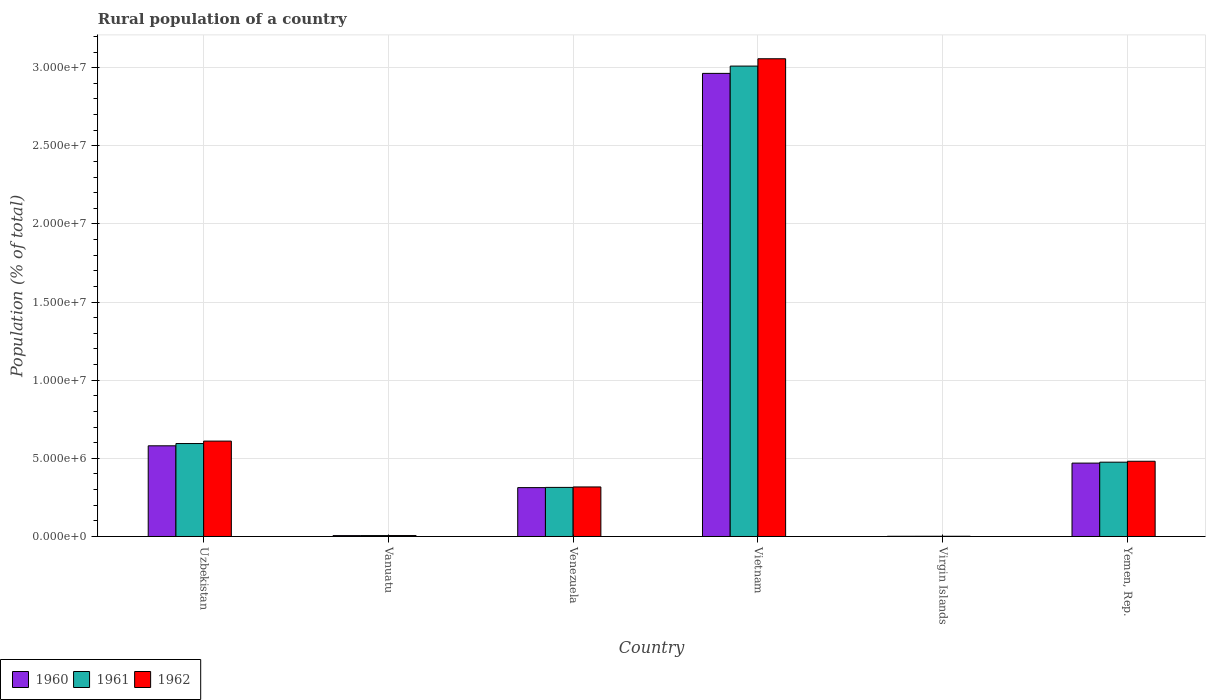Are the number of bars per tick equal to the number of legend labels?
Your answer should be very brief. Yes. Are the number of bars on each tick of the X-axis equal?
Make the answer very short. Yes. How many bars are there on the 3rd tick from the left?
Keep it short and to the point. 3. What is the label of the 1st group of bars from the left?
Offer a very short reply. Uzbekistan. What is the rural population in 1961 in Vietnam?
Your response must be concise. 3.01e+07. Across all countries, what is the maximum rural population in 1960?
Make the answer very short. 2.96e+07. Across all countries, what is the minimum rural population in 1960?
Your response must be concise. 1.39e+04. In which country was the rural population in 1961 maximum?
Provide a succinct answer. Vietnam. In which country was the rural population in 1960 minimum?
Ensure brevity in your answer.  Virgin Islands. What is the total rural population in 1962 in the graph?
Provide a succinct answer. 4.47e+07. What is the difference between the rural population in 1960 in Venezuela and that in Vietnam?
Provide a succinct answer. -2.65e+07. What is the difference between the rural population in 1962 in Vanuatu and the rural population in 1961 in Uzbekistan?
Provide a succinct answer. -5.89e+06. What is the average rural population in 1961 per country?
Your answer should be compact. 7.34e+06. What is the difference between the rural population of/in 1962 and rural population of/in 1960 in Venezuela?
Your response must be concise. 4.32e+04. In how many countries, is the rural population in 1961 greater than 27000000 %?
Provide a succinct answer. 1. What is the ratio of the rural population in 1962 in Vanuatu to that in Vietnam?
Provide a succinct answer. 0. Is the rural population in 1962 in Venezuela less than that in Vietnam?
Your answer should be very brief. Yes. Is the difference between the rural population in 1962 in Vietnam and Virgin Islands greater than the difference between the rural population in 1960 in Vietnam and Virgin Islands?
Your answer should be compact. Yes. What is the difference between the highest and the second highest rural population in 1961?
Provide a succinct answer. 2.53e+07. What is the difference between the highest and the lowest rural population in 1962?
Ensure brevity in your answer.  3.06e+07. Is the sum of the rural population in 1961 in Vanuatu and Venezuela greater than the maximum rural population in 1960 across all countries?
Your answer should be compact. No. What does the 3rd bar from the left in Vanuatu represents?
Keep it short and to the point. 1962. Are all the bars in the graph horizontal?
Your response must be concise. No. What is the difference between two consecutive major ticks on the Y-axis?
Your answer should be very brief. 5.00e+06. Are the values on the major ticks of Y-axis written in scientific E-notation?
Give a very brief answer. Yes. How are the legend labels stacked?
Offer a very short reply. Horizontal. What is the title of the graph?
Provide a short and direct response. Rural population of a country. What is the label or title of the Y-axis?
Ensure brevity in your answer.  Population (% of total). What is the Population (% of total) of 1960 in Uzbekistan?
Offer a terse response. 5.80e+06. What is the Population (% of total) in 1961 in Uzbekistan?
Offer a terse response. 5.95e+06. What is the Population (% of total) of 1962 in Uzbekistan?
Your response must be concise. 6.10e+06. What is the Population (% of total) of 1960 in Vanuatu?
Make the answer very short. 5.71e+04. What is the Population (% of total) of 1961 in Vanuatu?
Give a very brief answer. 5.88e+04. What is the Population (% of total) in 1962 in Vanuatu?
Your answer should be compact. 6.05e+04. What is the Population (% of total) of 1960 in Venezuela?
Your answer should be very brief. 3.13e+06. What is the Population (% of total) in 1961 in Venezuela?
Offer a terse response. 3.14e+06. What is the Population (% of total) of 1962 in Venezuela?
Your answer should be very brief. 3.17e+06. What is the Population (% of total) in 1960 in Vietnam?
Your response must be concise. 2.96e+07. What is the Population (% of total) of 1961 in Vietnam?
Your response must be concise. 3.01e+07. What is the Population (% of total) in 1962 in Vietnam?
Offer a very short reply. 3.06e+07. What is the Population (% of total) in 1960 in Virgin Islands?
Ensure brevity in your answer.  1.39e+04. What is the Population (% of total) of 1961 in Virgin Islands?
Ensure brevity in your answer.  1.44e+04. What is the Population (% of total) in 1962 in Virgin Islands?
Your answer should be compact. 1.48e+04. What is the Population (% of total) of 1960 in Yemen, Rep.?
Make the answer very short. 4.70e+06. What is the Population (% of total) of 1961 in Yemen, Rep.?
Offer a very short reply. 4.75e+06. What is the Population (% of total) in 1962 in Yemen, Rep.?
Provide a short and direct response. 4.81e+06. Across all countries, what is the maximum Population (% of total) in 1960?
Keep it short and to the point. 2.96e+07. Across all countries, what is the maximum Population (% of total) in 1961?
Make the answer very short. 3.01e+07. Across all countries, what is the maximum Population (% of total) in 1962?
Keep it short and to the point. 3.06e+07. Across all countries, what is the minimum Population (% of total) in 1960?
Make the answer very short. 1.39e+04. Across all countries, what is the minimum Population (% of total) of 1961?
Your answer should be very brief. 1.44e+04. Across all countries, what is the minimum Population (% of total) of 1962?
Make the answer very short. 1.48e+04. What is the total Population (% of total) of 1960 in the graph?
Your answer should be compact. 4.33e+07. What is the total Population (% of total) in 1961 in the graph?
Your response must be concise. 4.40e+07. What is the total Population (% of total) in 1962 in the graph?
Provide a short and direct response. 4.47e+07. What is the difference between the Population (% of total) in 1960 in Uzbekistan and that in Vanuatu?
Your answer should be very brief. 5.75e+06. What is the difference between the Population (% of total) in 1961 in Uzbekistan and that in Vanuatu?
Your answer should be very brief. 5.89e+06. What is the difference between the Population (% of total) of 1962 in Uzbekistan and that in Vanuatu?
Offer a very short reply. 6.04e+06. What is the difference between the Population (% of total) of 1960 in Uzbekistan and that in Venezuela?
Provide a succinct answer. 2.68e+06. What is the difference between the Population (% of total) of 1961 in Uzbekistan and that in Venezuela?
Offer a terse response. 2.81e+06. What is the difference between the Population (% of total) in 1962 in Uzbekistan and that in Venezuela?
Offer a very short reply. 2.93e+06. What is the difference between the Population (% of total) of 1960 in Uzbekistan and that in Vietnam?
Ensure brevity in your answer.  -2.38e+07. What is the difference between the Population (% of total) of 1961 in Uzbekistan and that in Vietnam?
Your response must be concise. -2.42e+07. What is the difference between the Population (% of total) in 1962 in Uzbekistan and that in Vietnam?
Ensure brevity in your answer.  -2.45e+07. What is the difference between the Population (% of total) of 1960 in Uzbekistan and that in Virgin Islands?
Your answer should be compact. 5.79e+06. What is the difference between the Population (% of total) in 1961 in Uzbekistan and that in Virgin Islands?
Offer a terse response. 5.93e+06. What is the difference between the Population (% of total) in 1962 in Uzbekistan and that in Virgin Islands?
Provide a succinct answer. 6.09e+06. What is the difference between the Population (% of total) in 1960 in Uzbekistan and that in Yemen, Rep.?
Your response must be concise. 1.11e+06. What is the difference between the Population (% of total) in 1961 in Uzbekistan and that in Yemen, Rep.?
Provide a succinct answer. 1.19e+06. What is the difference between the Population (% of total) of 1962 in Uzbekistan and that in Yemen, Rep.?
Make the answer very short. 1.29e+06. What is the difference between the Population (% of total) of 1960 in Vanuatu and that in Venezuela?
Provide a short and direct response. -3.07e+06. What is the difference between the Population (% of total) in 1961 in Vanuatu and that in Venezuela?
Give a very brief answer. -3.08e+06. What is the difference between the Population (% of total) in 1962 in Vanuatu and that in Venezuela?
Your answer should be very brief. -3.11e+06. What is the difference between the Population (% of total) in 1960 in Vanuatu and that in Vietnam?
Your response must be concise. -2.96e+07. What is the difference between the Population (% of total) of 1961 in Vanuatu and that in Vietnam?
Keep it short and to the point. -3.00e+07. What is the difference between the Population (% of total) of 1962 in Vanuatu and that in Vietnam?
Offer a terse response. -3.05e+07. What is the difference between the Population (% of total) in 1960 in Vanuatu and that in Virgin Islands?
Make the answer very short. 4.31e+04. What is the difference between the Population (% of total) of 1961 in Vanuatu and that in Virgin Islands?
Provide a succinct answer. 4.44e+04. What is the difference between the Population (% of total) of 1962 in Vanuatu and that in Virgin Islands?
Ensure brevity in your answer.  4.57e+04. What is the difference between the Population (% of total) of 1960 in Vanuatu and that in Yemen, Rep.?
Give a very brief answer. -4.64e+06. What is the difference between the Population (% of total) of 1961 in Vanuatu and that in Yemen, Rep.?
Ensure brevity in your answer.  -4.70e+06. What is the difference between the Population (% of total) of 1962 in Vanuatu and that in Yemen, Rep.?
Provide a short and direct response. -4.75e+06. What is the difference between the Population (% of total) of 1960 in Venezuela and that in Vietnam?
Your answer should be compact. -2.65e+07. What is the difference between the Population (% of total) of 1961 in Venezuela and that in Vietnam?
Your answer should be very brief. -2.70e+07. What is the difference between the Population (% of total) in 1962 in Venezuela and that in Vietnam?
Provide a short and direct response. -2.74e+07. What is the difference between the Population (% of total) in 1960 in Venezuela and that in Virgin Islands?
Provide a short and direct response. 3.11e+06. What is the difference between the Population (% of total) in 1961 in Venezuela and that in Virgin Islands?
Your answer should be very brief. 3.13e+06. What is the difference between the Population (% of total) of 1962 in Venezuela and that in Virgin Islands?
Provide a short and direct response. 3.16e+06. What is the difference between the Population (% of total) in 1960 in Venezuela and that in Yemen, Rep.?
Ensure brevity in your answer.  -1.57e+06. What is the difference between the Population (% of total) in 1961 in Venezuela and that in Yemen, Rep.?
Provide a succinct answer. -1.61e+06. What is the difference between the Population (% of total) of 1962 in Venezuela and that in Yemen, Rep.?
Your answer should be very brief. -1.64e+06. What is the difference between the Population (% of total) in 1960 in Vietnam and that in Virgin Islands?
Make the answer very short. 2.96e+07. What is the difference between the Population (% of total) in 1961 in Vietnam and that in Virgin Islands?
Keep it short and to the point. 3.01e+07. What is the difference between the Population (% of total) of 1962 in Vietnam and that in Virgin Islands?
Your answer should be compact. 3.06e+07. What is the difference between the Population (% of total) in 1960 in Vietnam and that in Yemen, Rep.?
Your response must be concise. 2.49e+07. What is the difference between the Population (% of total) in 1961 in Vietnam and that in Yemen, Rep.?
Offer a terse response. 2.53e+07. What is the difference between the Population (% of total) of 1962 in Vietnam and that in Yemen, Rep.?
Make the answer very short. 2.58e+07. What is the difference between the Population (% of total) of 1960 in Virgin Islands and that in Yemen, Rep.?
Provide a short and direct response. -4.68e+06. What is the difference between the Population (% of total) in 1961 in Virgin Islands and that in Yemen, Rep.?
Give a very brief answer. -4.74e+06. What is the difference between the Population (% of total) in 1962 in Virgin Islands and that in Yemen, Rep.?
Provide a succinct answer. -4.80e+06. What is the difference between the Population (% of total) of 1960 in Uzbekistan and the Population (% of total) of 1961 in Vanuatu?
Your response must be concise. 5.74e+06. What is the difference between the Population (% of total) of 1960 in Uzbekistan and the Population (% of total) of 1962 in Vanuatu?
Your response must be concise. 5.74e+06. What is the difference between the Population (% of total) in 1961 in Uzbekistan and the Population (% of total) in 1962 in Vanuatu?
Give a very brief answer. 5.89e+06. What is the difference between the Population (% of total) in 1960 in Uzbekistan and the Population (% of total) in 1961 in Venezuela?
Give a very brief answer. 2.66e+06. What is the difference between the Population (% of total) in 1960 in Uzbekistan and the Population (% of total) in 1962 in Venezuela?
Your answer should be very brief. 2.63e+06. What is the difference between the Population (% of total) in 1961 in Uzbekistan and the Population (% of total) in 1962 in Venezuela?
Your response must be concise. 2.78e+06. What is the difference between the Population (% of total) in 1960 in Uzbekistan and the Population (% of total) in 1961 in Vietnam?
Keep it short and to the point. -2.43e+07. What is the difference between the Population (% of total) of 1960 in Uzbekistan and the Population (% of total) of 1962 in Vietnam?
Make the answer very short. -2.48e+07. What is the difference between the Population (% of total) of 1961 in Uzbekistan and the Population (% of total) of 1962 in Vietnam?
Your answer should be compact. -2.46e+07. What is the difference between the Population (% of total) of 1960 in Uzbekistan and the Population (% of total) of 1961 in Virgin Islands?
Your answer should be very brief. 5.79e+06. What is the difference between the Population (% of total) of 1960 in Uzbekistan and the Population (% of total) of 1962 in Virgin Islands?
Offer a very short reply. 5.79e+06. What is the difference between the Population (% of total) of 1961 in Uzbekistan and the Population (% of total) of 1962 in Virgin Islands?
Provide a succinct answer. 5.93e+06. What is the difference between the Population (% of total) of 1960 in Uzbekistan and the Population (% of total) of 1961 in Yemen, Rep.?
Offer a terse response. 1.05e+06. What is the difference between the Population (% of total) of 1960 in Uzbekistan and the Population (% of total) of 1962 in Yemen, Rep.?
Your response must be concise. 9.89e+05. What is the difference between the Population (% of total) in 1961 in Uzbekistan and the Population (% of total) in 1962 in Yemen, Rep.?
Your answer should be very brief. 1.13e+06. What is the difference between the Population (% of total) in 1960 in Vanuatu and the Population (% of total) in 1961 in Venezuela?
Offer a very short reply. -3.08e+06. What is the difference between the Population (% of total) in 1960 in Vanuatu and the Population (% of total) in 1962 in Venezuela?
Make the answer very short. -3.11e+06. What is the difference between the Population (% of total) of 1961 in Vanuatu and the Population (% of total) of 1962 in Venezuela?
Offer a very short reply. -3.11e+06. What is the difference between the Population (% of total) of 1960 in Vanuatu and the Population (% of total) of 1961 in Vietnam?
Make the answer very short. -3.00e+07. What is the difference between the Population (% of total) of 1960 in Vanuatu and the Population (% of total) of 1962 in Vietnam?
Ensure brevity in your answer.  -3.05e+07. What is the difference between the Population (% of total) of 1961 in Vanuatu and the Population (% of total) of 1962 in Vietnam?
Give a very brief answer. -3.05e+07. What is the difference between the Population (% of total) of 1960 in Vanuatu and the Population (% of total) of 1961 in Virgin Islands?
Your answer should be very brief. 4.27e+04. What is the difference between the Population (% of total) of 1960 in Vanuatu and the Population (% of total) of 1962 in Virgin Islands?
Provide a succinct answer. 4.23e+04. What is the difference between the Population (% of total) of 1961 in Vanuatu and the Population (% of total) of 1962 in Virgin Islands?
Make the answer very short. 4.40e+04. What is the difference between the Population (% of total) in 1960 in Vanuatu and the Population (% of total) in 1961 in Yemen, Rep.?
Provide a succinct answer. -4.70e+06. What is the difference between the Population (% of total) in 1960 in Vanuatu and the Population (% of total) in 1962 in Yemen, Rep.?
Ensure brevity in your answer.  -4.76e+06. What is the difference between the Population (% of total) of 1961 in Vanuatu and the Population (% of total) of 1962 in Yemen, Rep.?
Ensure brevity in your answer.  -4.76e+06. What is the difference between the Population (% of total) of 1960 in Venezuela and the Population (% of total) of 1961 in Vietnam?
Your answer should be compact. -2.70e+07. What is the difference between the Population (% of total) in 1960 in Venezuela and the Population (% of total) in 1962 in Vietnam?
Keep it short and to the point. -2.74e+07. What is the difference between the Population (% of total) of 1961 in Venezuela and the Population (% of total) of 1962 in Vietnam?
Ensure brevity in your answer.  -2.74e+07. What is the difference between the Population (% of total) of 1960 in Venezuela and the Population (% of total) of 1961 in Virgin Islands?
Give a very brief answer. 3.11e+06. What is the difference between the Population (% of total) in 1960 in Venezuela and the Population (% of total) in 1962 in Virgin Islands?
Provide a succinct answer. 3.11e+06. What is the difference between the Population (% of total) in 1961 in Venezuela and the Population (% of total) in 1962 in Virgin Islands?
Keep it short and to the point. 3.13e+06. What is the difference between the Population (% of total) of 1960 in Venezuela and the Population (% of total) of 1961 in Yemen, Rep.?
Your answer should be compact. -1.63e+06. What is the difference between the Population (% of total) in 1960 in Venezuela and the Population (% of total) in 1962 in Yemen, Rep.?
Give a very brief answer. -1.69e+06. What is the difference between the Population (% of total) of 1961 in Venezuela and the Population (% of total) of 1962 in Yemen, Rep.?
Make the answer very short. -1.67e+06. What is the difference between the Population (% of total) of 1960 in Vietnam and the Population (% of total) of 1961 in Virgin Islands?
Provide a succinct answer. 2.96e+07. What is the difference between the Population (% of total) in 1960 in Vietnam and the Population (% of total) in 1962 in Virgin Islands?
Ensure brevity in your answer.  2.96e+07. What is the difference between the Population (% of total) of 1961 in Vietnam and the Population (% of total) of 1962 in Virgin Islands?
Provide a succinct answer. 3.01e+07. What is the difference between the Population (% of total) of 1960 in Vietnam and the Population (% of total) of 1961 in Yemen, Rep.?
Give a very brief answer. 2.49e+07. What is the difference between the Population (% of total) in 1960 in Vietnam and the Population (% of total) in 1962 in Yemen, Rep.?
Your answer should be compact. 2.48e+07. What is the difference between the Population (% of total) of 1961 in Vietnam and the Population (% of total) of 1962 in Yemen, Rep.?
Offer a very short reply. 2.53e+07. What is the difference between the Population (% of total) of 1960 in Virgin Islands and the Population (% of total) of 1961 in Yemen, Rep.?
Offer a very short reply. -4.74e+06. What is the difference between the Population (% of total) in 1960 in Virgin Islands and the Population (% of total) in 1962 in Yemen, Rep.?
Your answer should be very brief. -4.80e+06. What is the difference between the Population (% of total) of 1961 in Virgin Islands and the Population (% of total) of 1962 in Yemen, Rep.?
Your response must be concise. -4.80e+06. What is the average Population (% of total) in 1960 per country?
Ensure brevity in your answer.  7.22e+06. What is the average Population (% of total) in 1961 per country?
Ensure brevity in your answer.  7.34e+06. What is the average Population (% of total) in 1962 per country?
Provide a short and direct response. 7.46e+06. What is the difference between the Population (% of total) in 1960 and Population (% of total) in 1961 in Uzbekistan?
Keep it short and to the point. -1.45e+05. What is the difference between the Population (% of total) of 1960 and Population (% of total) of 1962 in Uzbekistan?
Provide a short and direct response. -3.01e+05. What is the difference between the Population (% of total) of 1961 and Population (% of total) of 1962 in Uzbekistan?
Keep it short and to the point. -1.56e+05. What is the difference between the Population (% of total) of 1960 and Population (% of total) of 1961 in Vanuatu?
Give a very brief answer. -1680. What is the difference between the Population (% of total) in 1960 and Population (% of total) in 1962 in Vanuatu?
Offer a terse response. -3433. What is the difference between the Population (% of total) of 1961 and Population (% of total) of 1962 in Vanuatu?
Offer a terse response. -1753. What is the difference between the Population (% of total) of 1960 and Population (% of total) of 1961 in Venezuela?
Offer a terse response. -1.41e+04. What is the difference between the Population (% of total) in 1960 and Population (% of total) in 1962 in Venezuela?
Make the answer very short. -4.32e+04. What is the difference between the Population (% of total) of 1961 and Population (% of total) of 1962 in Venezuela?
Provide a short and direct response. -2.91e+04. What is the difference between the Population (% of total) in 1960 and Population (% of total) in 1961 in Vietnam?
Provide a succinct answer. -4.67e+05. What is the difference between the Population (% of total) of 1960 and Population (% of total) of 1962 in Vietnam?
Provide a short and direct response. -9.35e+05. What is the difference between the Population (% of total) of 1961 and Population (% of total) of 1962 in Vietnam?
Your answer should be compact. -4.68e+05. What is the difference between the Population (% of total) of 1960 and Population (% of total) of 1961 in Virgin Islands?
Ensure brevity in your answer.  -441. What is the difference between the Population (% of total) of 1960 and Population (% of total) of 1962 in Virgin Islands?
Your response must be concise. -869. What is the difference between the Population (% of total) of 1961 and Population (% of total) of 1962 in Virgin Islands?
Offer a terse response. -428. What is the difference between the Population (% of total) in 1960 and Population (% of total) in 1961 in Yemen, Rep.?
Provide a succinct answer. -5.87e+04. What is the difference between the Population (% of total) in 1960 and Population (% of total) in 1962 in Yemen, Rep.?
Ensure brevity in your answer.  -1.18e+05. What is the difference between the Population (% of total) of 1961 and Population (% of total) of 1962 in Yemen, Rep.?
Your answer should be very brief. -5.95e+04. What is the ratio of the Population (% of total) of 1960 in Uzbekistan to that in Vanuatu?
Offer a very short reply. 101.67. What is the ratio of the Population (% of total) of 1961 in Uzbekistan to that in Vanuatu?
Offer a terse response. 101.23. What is the ratio of the Population (% of total) in 1962 in Uzbekistan to that in Vanuatu?
Ensure brevity in your answer.  100.89. What is the ratio of the Population (% of total) of 1960 in Uzbekistan to that in Venezuela?
Your answer should be compact. 1.86. What is the ratio of the Population (% of total) of 1961 in Uzbekistan to that in Venezuela?
Make the answer very short. 1.89. What is the ratio of the Population (% of total) of 1962 in Uzbekistan to that in Venezuela?
Give a very brief answer. 1.93. What is the ratio of the Population (% of total) of 1960 in Uzbekistan to that in Vietnam?
Give a very brief answer. 0.2. What is the ratio of the Population (% of total) of 1961 in Uzbekistan to that in Vietnam?
Offer a very short reply. 0.2. What is the ratio of the Population (% of total) of 1962 in Uzbekistan to that in Vietnam?
Your answer should be compact. 0.2. What is the ratio of the Population (% of total) in 1960 in Uzbekistan to that in Virgin Islands?
Your answer should be very brief. 416.67. What is the ratio of the Population (% of total) in 1961 in Uzbekistan to that in Virgin Islands?
Offer a very short reply. 413.97. What is the ratio of the Population (% of total) of 1962 in Uzbekistan to that in Virgin Islands?
Keep it short and to the point. 412.56. What is the ratio of the Population (% of total) of 1960 in Uzbekistan to that in Yemen, Rep.?
Offer a very short reply. 1.24. What is the ratio of the Population (% of total) of 1961 in Uzbekistan to that in Yemen, Rep.?
Give a very brief answer. 1.25. What is the ratio of the Population (% of total) of 1962 in Uzbekistan to that in Yemen, Rep.?
Provide a short and direct response. 1.27. What is the ratio of the Population (% of total) of 1960 in Vanuatu to that in Venezuela?
Your answer should be compact. 0.02. What is the ratio of the Population (% of total) in 1961 in Vanuatu to that in Venezuela?
Your answer should be compact. 0.02. What is the ratio of the Population (% of total) of 1962 in Vanuatu to that in Venezuela?
Your answer should be very brief. 0.02. What is the ratio of the Population (% of total) in 1960 in Vanuatu to that in Vietnam?
Offer a very short reply. 0. What is the ratio of the Population (% of total) in 1961 in Vanuatu to that in Vietnam?
Provide a short and direct response. 0. What is the ratio of the Population (% of total) in 1962 in Vanuatu to that in Vietnam?
Ensure brevity in your answer.  0. What is the ratio of the Population (% of total) of 1960 in Vanuatu to that in Virgin Islands?
Your answer should be very brief. 4.1. What is the ratio of the Population (% of total) in 1961 in Vanuatu to that in Virgin Islands?
Your answer should be compact. 4.09. What is the ratio of the Population (% of total) in 1962 in Vanuatu to that in Virgin Islands?
Offer a very short reply. 4.09. What is the ratio of the Population (% of total) in 1960 in Vanuatu to that in Yemen, Rep.?
Keep it short and to the point. 0.01. What is the ratio of the Population (% of total) of 1961 in Vanuatu to that in Yemen, Rep.?
Your answer should be very brief. 0.01. What is the ratio of the Population (% of total) of 1962 in Vanuatu to that in Yemen, Rep.?
Provide a short and direct response. 0.01. What is the ratio of the Population (% of total) of 1960 in Venezuela to that in Vietnam?
Provide a succinct answer. 0.11. What is the ratio of the Population (% of total) of 1961 in Venezuela to that in Vietnam?
Provide a succinct answer. 0.1. What is the ratio of the Population (% of total) in 1962 in Venezuela to that in Vietnam?
Offer a terse response. 0.1. What is the ratio of the Population (% of total) of 1960 in Venezuela to that in Virgin Islands?
Offer a terse response. 224.55. What is the ratio of the Population (% of total) of 1961 in Venezuela to that in Virgin Islands?
Provide a succinct answer. 218.64. What is the ratio of the Population (% of total) in 1962 in Venezuela to that in Virgin Islands?
Your response must be concise. 214.28. What is the ratio of the Population (% of total) in 1960 in Venezuela to that in Yemen, Rep.?
Give a very brief answer. 0.67. What is the ratio of the Population (% of total) in 1961 in Venezuela to that in Yemen, Rep.?
Your answer should be very brief. 0.66. What is the ratio of the Population (% of total) of 1962 in Venezuela to that in Yemen, Rep.?
Make the answer very short. 0.66. What is the ratio of the Population (% of total) of 1960 in Vietnam to that in Virgin Islands?
Give a very brief answer. 2127.94. What is the ratio of the Population (% of total) in 1961 in Vietnam to that in Virgin Islands?
Provide a succinct answer. 2095.13. What is the ratio of the Population (% of total) of 1962 in Vietnam to that in Virgin Islands?
Give a very brief answer. 2066.18. What is the ratio of the Population (% of total) in 1960 in Vietnam to that in Yemen, Rep.?
Offer a terse response. 6.31. What is the ratio of the Population (% of total) in 1961 in Vietnam to that in Yemen, Rep.?
Give a very brief answer. 6.33. What is the ratio of the Population (% of total) in 1962 in Vietnam to that in Yemen, Rep.?
Provide a succinct answer. 6.35. What is the ratio of the Population (% of total) of 1960 in Virgin Islands to that in Yemen, Rep.?
Ensure brevity in your answer.  0. What is the ratio of the Population (% of total) of 1961 in Virgin Islands to that in Yemen, Rep.?
Make the answer very short. 0. What is the ratio of the Population (% of total) in 1962 in Virgin Islands to that in Yemen, Rep.?
Provide a succinct answer. 0. What is the difference between the highest and the second highest Population (% of total) in 1960?
Ensure brevity in your answer.  2.38e+07. What is the difference between the highest and the second highest Population (% of total) of 1961?
Give a very brief answer. 2.42e+07. What is the difference between the highest and the second highest Population (% of total) in 1962?
Keep it short and to the point. 2.45e+07. What is the difference between the highest and the lowest Population (% of total) of 1960?
Provide a succinct answer. 2.96e+07. What is the difference between the highest and the lowest Population (% of total) in 1961?
Your answer should be very brief. 3.01e+07. What is the difference between the highest and the lowest Population (% of total) of 1962?
Provide a succinct answer. 3.06e+07. 